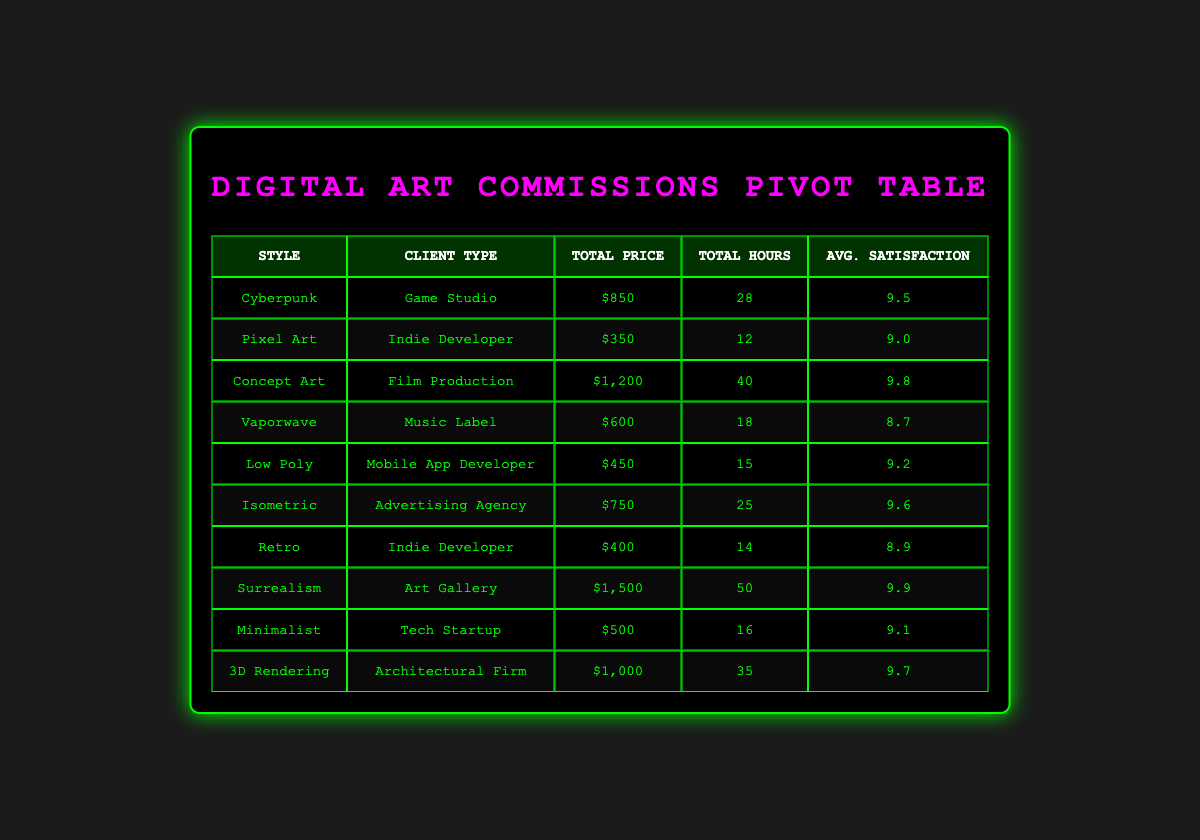What is the total price for commissions in the Vaporwave style? From the table, under the Vaporwave row, the total price listed is $600.
Answer: $600 Which client type requested the highest-priced commission? Looking at the Total Price column, the highest value is $1,500 for the Art Gallery in Surrealism style, making it the highest-priced commission.
Answer: Art Gallery What is the average client satisfaction for commissions made by Indie Developers? The table shows two commissions for Indie Developers: one for Pixel Art (client satisfaction 9.0) and one for Retro (client satisfaction 8.9). To find the average, add 9.0 and 8.9, giving 17.9, then divide by 2, resulting in 8.95.
Answer: 8.95 Are there any commissions where the artist is Sophia Nguyen? The table has two entries for Sophia Nguyen: one for Concept Art and one for Surrealism, confirming that yes, there are commissions by her.
Answer: Yes What is the total hours spent for all commissions in the Isometric style? The Isometric row shows a total of 25 hours spent, as per the Hours Spent column.
Answer: 25 If we consider just the Tech Startup and Game Studio as client types, which one had a lower client satisfaction? The Tech Startup has a satisfaction of 9.1, while the Game Studio has 9.5. Since 9.1 is less than 9.5, the Tech Startup had a lower client satisfaction.
Answer: Tech Startup What is the difference in total prices between the highest and lowest commission styles? The highest-priced commission is for Surrealism at $1,500, and the lowest-priced commission is for Pixel Art at $350. The difference is 1,500 - 350 = $1,150.
Answer: $1,150 How many commission styles are represented in total for the Music Label client type? The table shows only one commission for the Music Label, which is in the Vaporwave style. Hence, there is a total of 1 style represented.
Answer: 1 What is the total number of hours spent across all commissions by Aiden Patel? Aiden Patel has two commissions: 15 hours for Low Poly and 35 hours for 3D Rendering. The total is 15 + 35 = 50 hours.
Answer: 50 